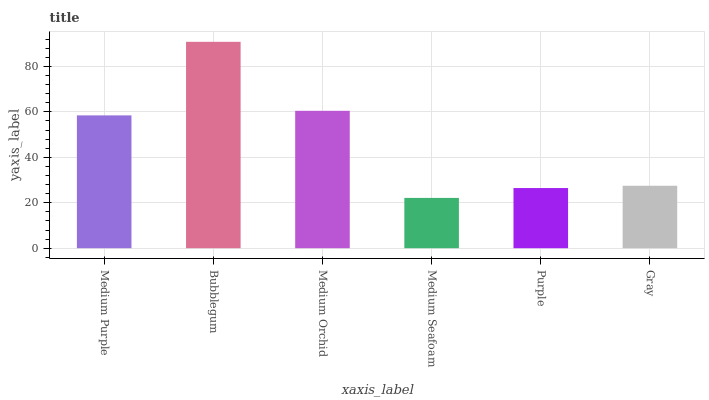Is Medium Seafoam the minimum?
Answer yes or no. Yes. Is Bubblegum the maximum?
Answer yes or no. Yes. Is Medium Orchid the minimum?
Answer yes or no. No. Is Medium Orchid the maximum?
Answer yes or no. No. Is Bubblegum greater than Medium Orchid?
Answer yes or no. Yes. Is Medium Orchid less than Bubblegum?
Answer yes or no. Yes. Is Medium Orchid greater than Bubblegum?
Answer yes or no. No. Is Bubblegum less than Medium Orchid?
Answer yes or no. No. Is Medium Purple the high median?
Answer yes or no. Yes. Is Gray the low median?
Answer yes or no. Yes. Is Purple the high median?
Answer yes or no. No. Is Purple the low median?
Answer yes or no. No. 